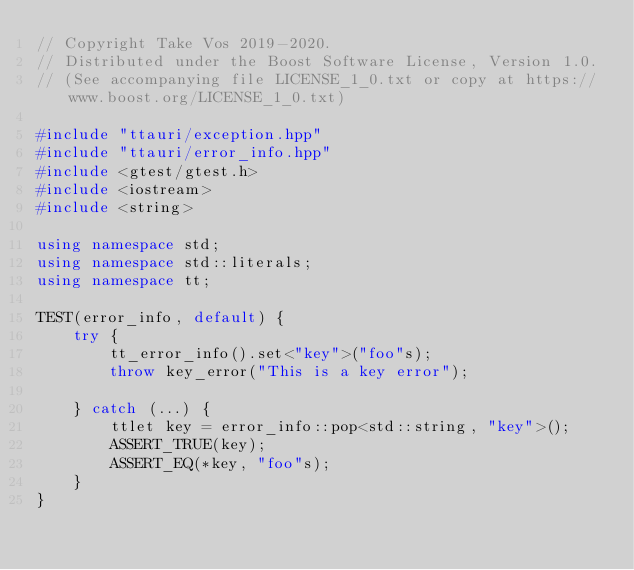<code> <loc_0><loc_0><loc_500><loc_500><_C++_>// Copyright Take Vos 2019-2020.
// Distributed under the Boost Software License, Version 1.0.
// (See accompanying file LICENSE_1_0.txt or copy at https://www.boost.org/LICENSE_1_0.txt)

#include "ttauri/exception.hpp"
#include "ttauri/error_info.hpp"
#include <gtest/gtest.h>
#include <iostream>
#include <string>

using namespace std;
using namespace std::literals;
using namespace tt;

TEST(error_info, default) {
    try {
        tt_error_info().set<"key">("foo"s);
        throw key_error("This is a key error");

    } catch (...) {
        ttlet key = error_info::pop<std::string, "key">();
        ASSERT_TRUE(key);
        ASSERT_EQ(*key, "foo"s);
    }
}
</code> 